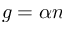Convert formula to latex. <formula><loc_0><loc_0><loc_500><loc_500>g = \alpha n</formula> 